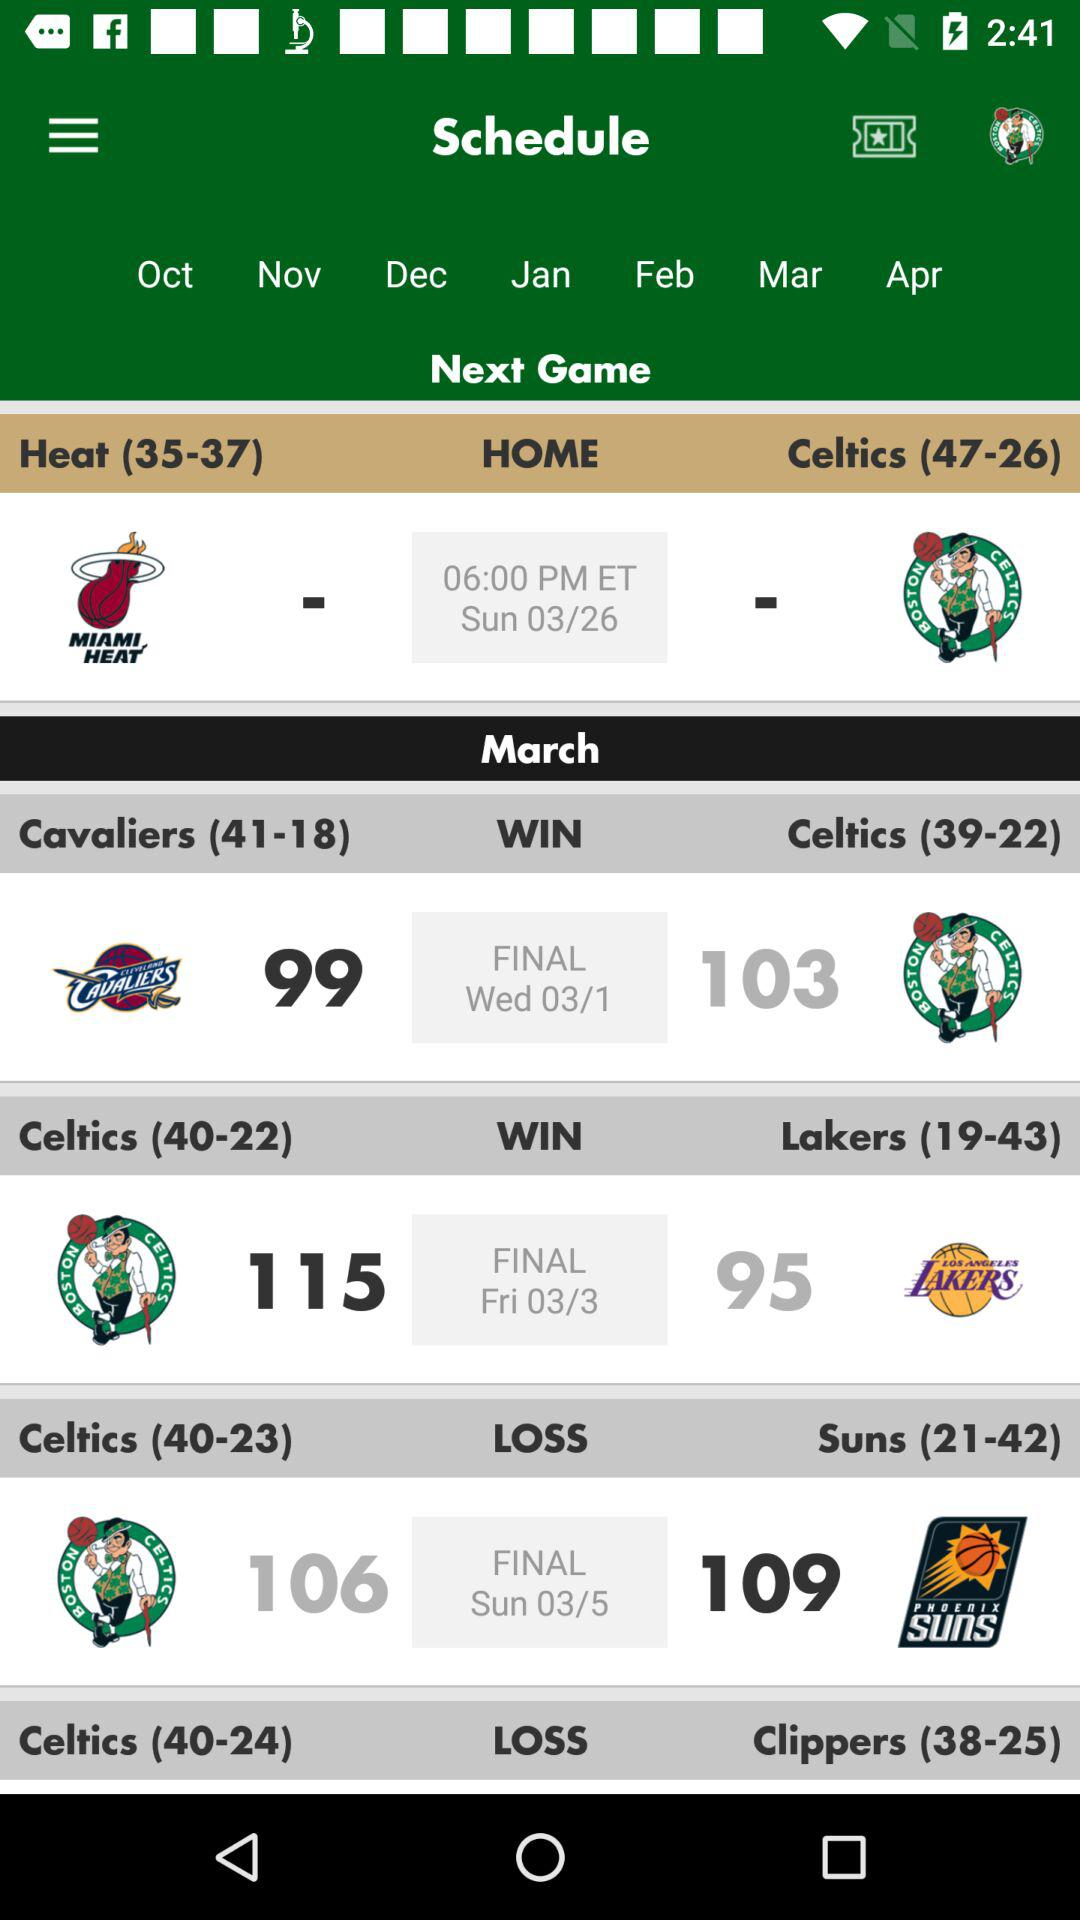Which teams play the next match? The teams playing in the next match are "Heat" and "Celtics". 